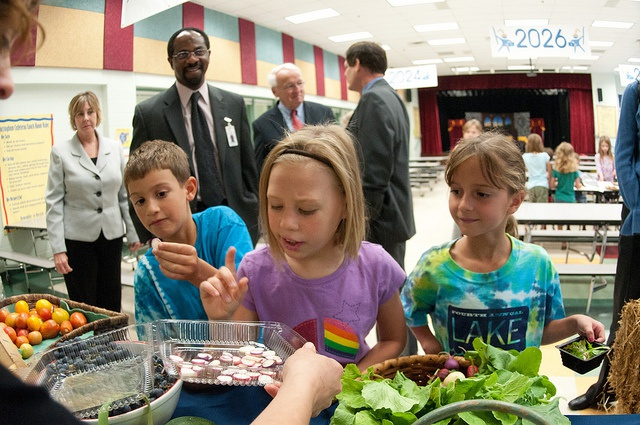Describe the objects in this image and their specific colors. I can see people in black, brown, purple, and maroon tones, people in black, maroon, and gray tones, people in black, blue, gray, brown, and maroon tones, people in black, darkgray, lightgray, and gray tones, and people in black, gray, ivory, and darkgray tones in this image. 